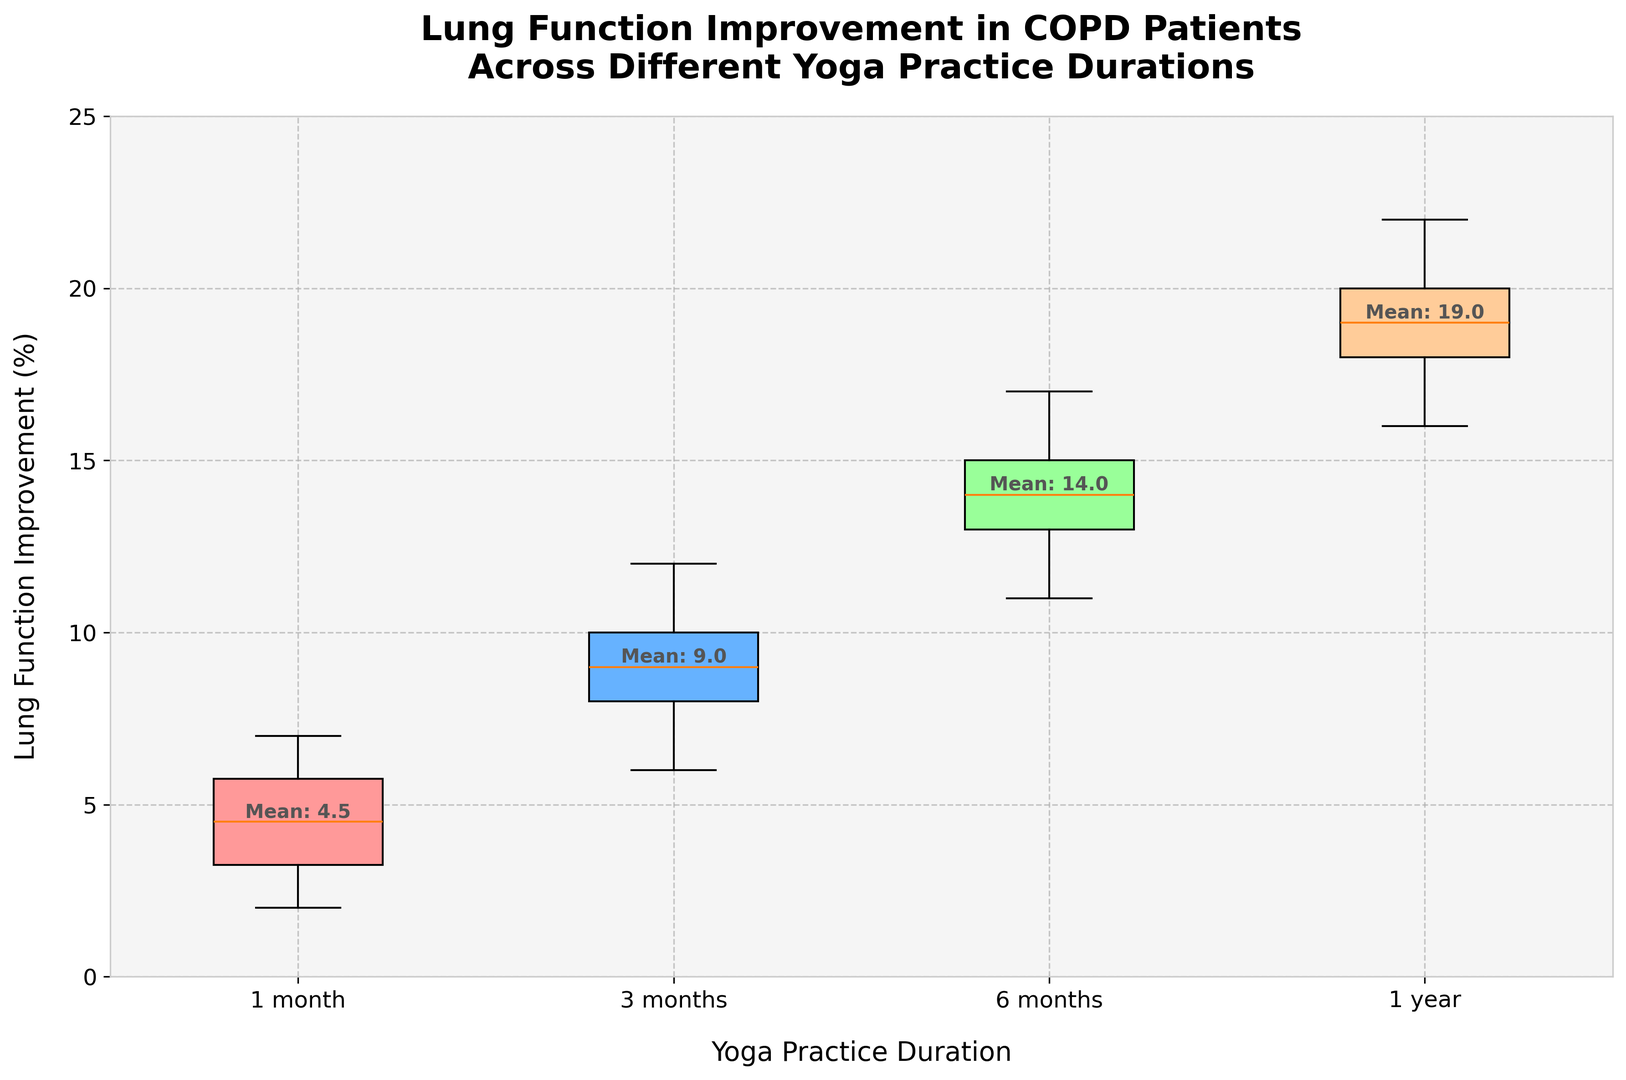What is the median lung function improvement for patients practicing yoga for 1 month? To find the median value for 1 month, list the data points in ascending order: [2, 3, 3, 4, 4, 5, 5, 6, 6, 7]. The median is the middle value, which is the average of the 5th and 6th values, (4 + 5) / 2 = 4.5
Answer: 4.5 Which group shows the highest median lung function improvement? Compare the median values across all groups. The median values are: 
- 1 month: 4.5
- 3 months: 9
- 6 months: 14
- 1 year: 19. 
Therefore, the group practicing yoga for 1 year has the highest median improvement
Answer: 1 year How does the lung function improvement for 1 month compare to 6 months based on the box plot? Examine the central tendencies (medians) of the two groups. The median for 1 month is 4.5, while for 6 months it is 14. The lung function improvement is significantly higher in the 6 months group compared to the 1 month group
Answer: 6 months is higher What is the range of lung function improvement for patients practicing yoga for 3 months? The range is the difference between the maximum and minimum values. For the 3 months group, the minimum is 6 and the maximum is 12. The range is 12 - 6 = 6
Answer: 6 Which group has the most consistent results based on the spread of the data? Consistency can be assessed by the spread of the data, with a smaller spread indicating greater consistency. The groups with smallest IQR (2) are the most consistent. Therefore, groups 3 months, 6 months, and 1 year show the most consistency
Answer: 3 months, 6 months, 1 year What is the average lung function improvement for patients practicing yoga for 1 year? To find the average value, sum all the data points and divide by the number of points: (18 + 20 + 17 + 19 + 21 + 16 + 22 + 19 + 18 + 20) / 10 = 19
Answer: 19 